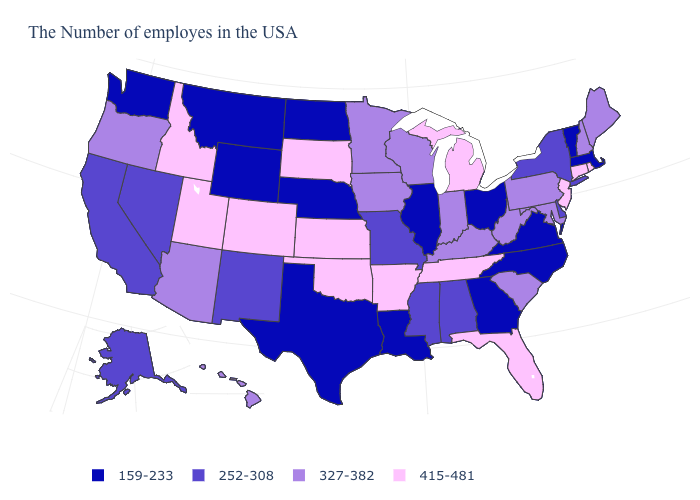What is the value of Hawaii?
Write a very short answer. 327-382. What is the value of Hawaii?
Give a very brief answer. 327-382. What is the value of North Carolina?
Be succinct. 159-233. Among the states that border California , does Nevada have the highest value?
Write a very short answer. No. Does Vermont have the lowest value in the USA?
Keep it brief. Yes. Does Florida have a lower value than Utah?
Write a very short answer. No. Name the states that have a value in the range 415-481?
Keep it brief. Rhode Island, Connecticut, New Jersey, Florida, Michigan, Tennessee, Arkansas, Kansas, Oklahoma, South Dakota, Colorado, Utah, Idaho. Name the states that have a value in the range 415-481?
Short answer required. Rhode Island, Connecticut, New Jersey, Florida, Michigan, Tennessee, Arkansas, Kansas, Oklahoma, South Dakota, Colorado, Utah, Idaho. What is the highest value in states that border New Jersey?
Give a very brief answer. 327-382. What is the value of Delaware?
Keep it brief. 252-308. What is the highest value in the USA?
Answer briefly. 415-481. What is the value of Colorado?
Give a very brief answer. 415-481. What is the value of Vermont?
Be succinct. 159-233. Which states have the lowest value in the MidWest?
Quick response, please. Ohio, Illinois, Nebraska, North Dakota. Does Connecticut have the highest value in the Northeast?
Be succinct. Yes. 